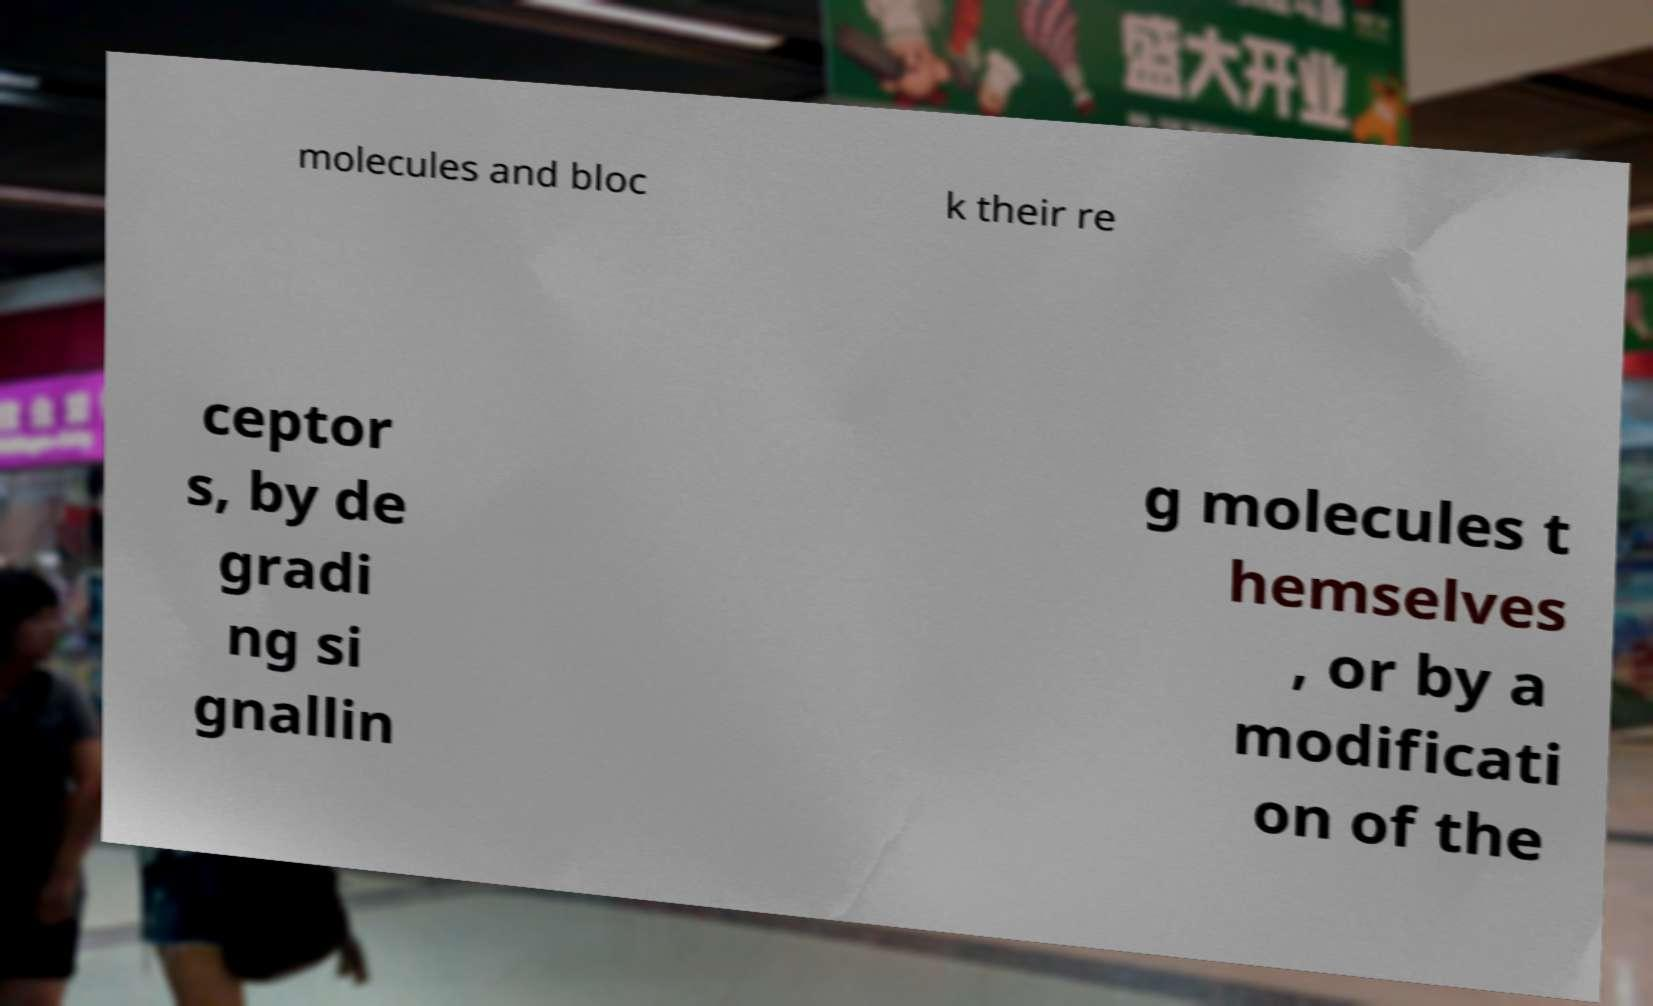What messages or text are displayed in this image? I need them in a readable, typed format. molecules and bloc k their re ceptor s, by de gradi ng si gnallin g molecules t hemselves , or by a modificati on of the 